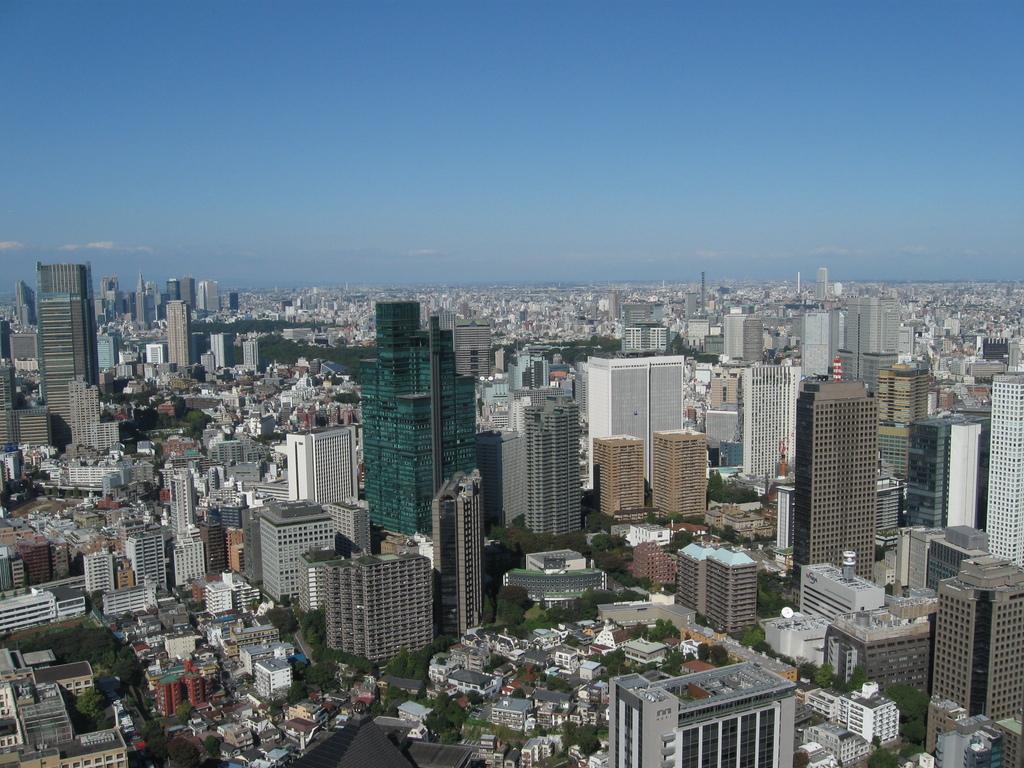How would you summarize this image in a sentence or two? In this picture I can see the city. In that city I can see many buildings, skyscrapers, house, trees, roads and river. At the I can see the sky and clouds. 